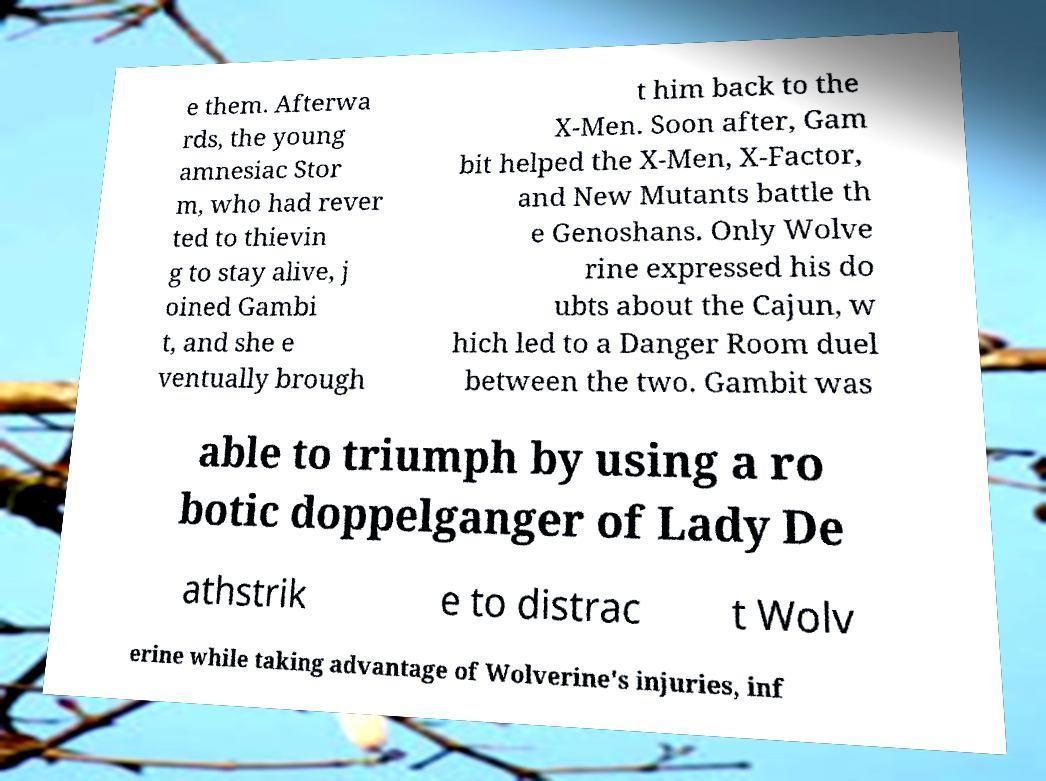Can you read and provide the text displayed in the image?This photo seems to have some interesting text. Can you extract and type it out for me? e them. Afterwa rds, the young amnesiac Stor m, who had rever ted to thievin g to stay alive, j oined Gambi t, and she e ventually brough t him back to the X-Men. Soon after, Gam bit helped the X-Men, X-Factor, and New Mutants battle th e Genoshans. Only Wolve rine expressed his do ubts about the Cajun, w hich led to a Danger Room duel between the two. Gambit was able to triumph by using a ro botic doppelganger of Lady De athstrik e to distrac t Wolv erine while taking advantage of Wolverine's injuries, inf 